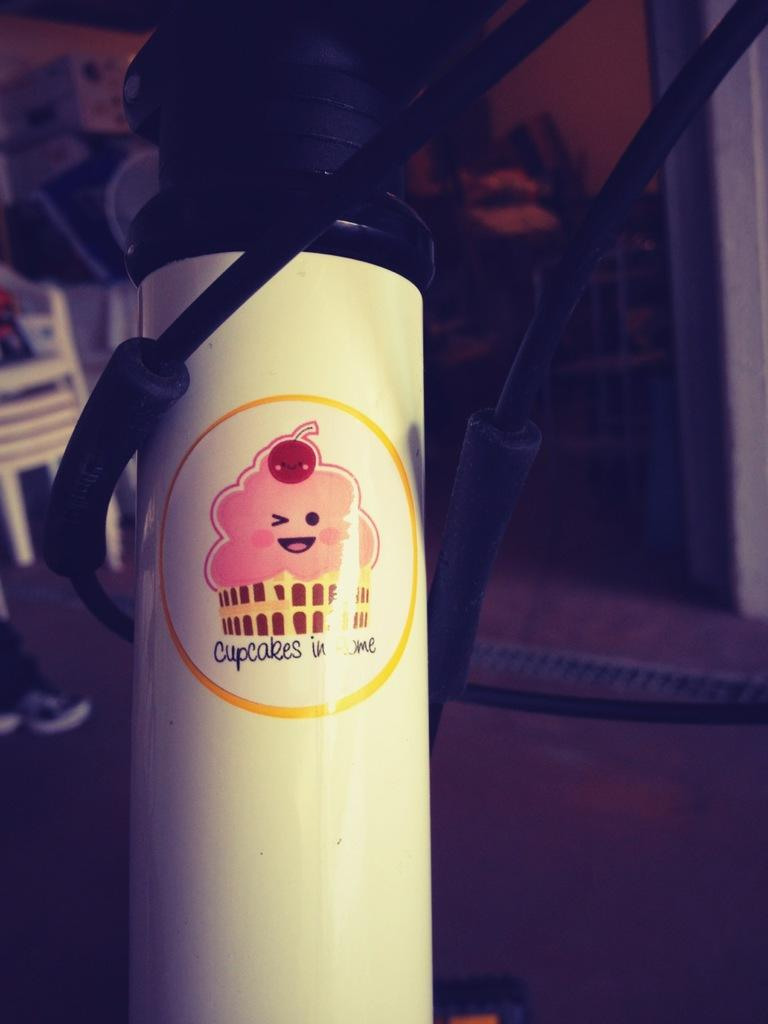<image>
Relay a brief, clear account of the picture shown. A container has a smily face as says cupcakes in me. 